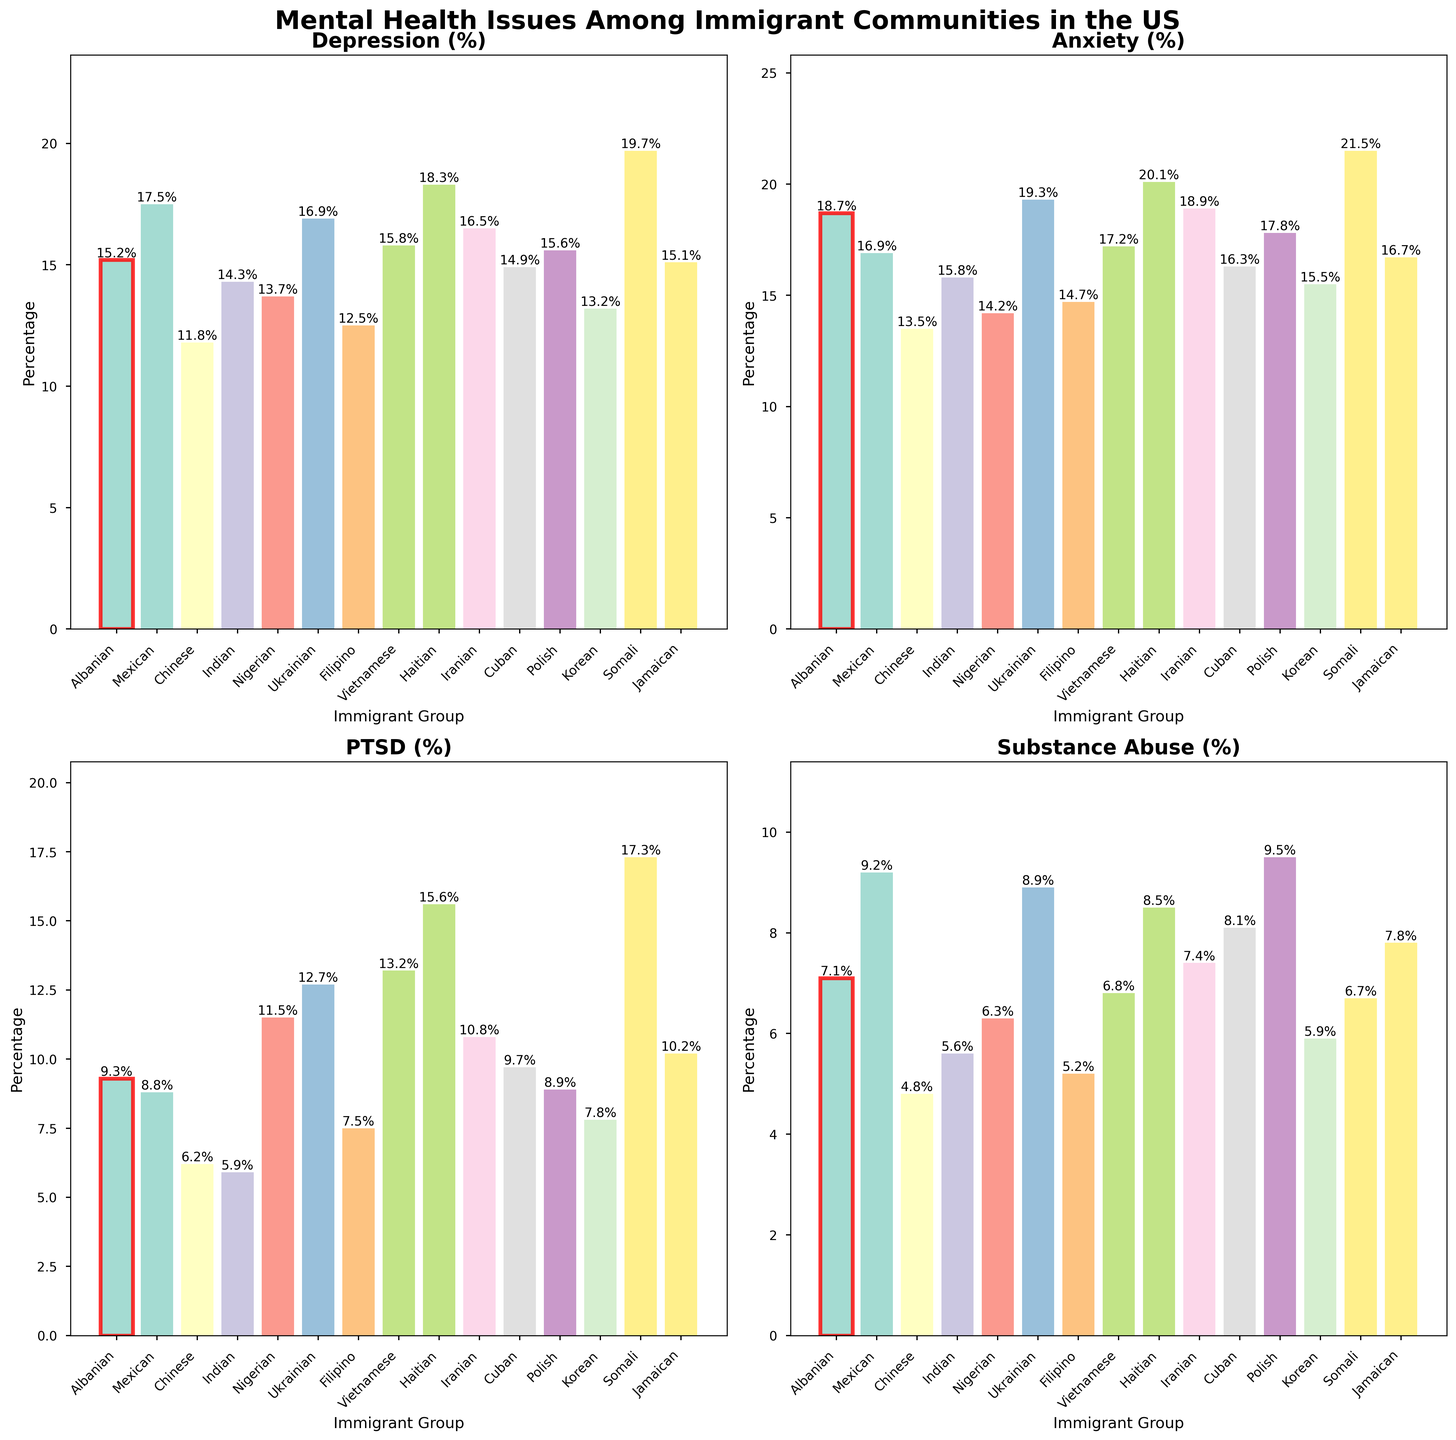Which group has the highest percentage of substance abuse? Look at the "Substance Abuse (%)" subplot and find the tallest bar. The Nigerian group has the highest percentage of substance abuse at 9.5%.
Answer: Nigerian Which immigrant group has the lowest percentage of PTSD? Refer to the "PTSD (%)" subplot and identify the shortest bar. The Indian group has the lowest percentage of PTSD at 5.9%.
Answer: Indian What's the average percentage of depression across all immigrant groups? Add the percentages of depression for all immigrant groups and divide by the number of groups. Calculation: (15.2 + 17.5 + 11.8 + 14.3 + 13.7 + 16.9 + 12.5 + 15.8 + 18.3 + 16.5 + 14.9 + 15.6 + 13.2 + 19.7 + 15.1) / 15 ≈ 15.3%
Answer: 15.3% How do the anxiety percentages of the Haitian and Somali groups compare visually? Both groups have their bars highlighted in the "Anxiety (%)" subplot. The Somali bar is slightly taller than the Haitian bar. The Somali group's anxiety percentage is 21.5%, and the Haitian group's anxiety percentage is 20.1%.
Answer: Somali > Haitian Which group has a higher percentage of PTSD, the Vietnamese or the Ukrainian? Look at the heights of the bars in the "PTSD (%)" subplot for the Vietnamese and Ukrainian groups. The Vietnamese group has a higher PTSD percentage (13.2%) compared to the Ukrainian group (12.7%).
Answer: Vietnamese Identify the immigrant group with a red-bordered bar in the subplots. The Albanian group's bars are highlighted with a red border in all subplots, making them easy to spot. The percentages for depression, anxiety, PTSD, and substance abuse are 15.2%, 18.7%, 9.3%, and 7.1%, respectively.
Answer: Albanian What's the total percentage of depression and anxiety in the Cuban group? Add the percentages of depression and anxiety for the Cuban group. The depression percentage is 14.9%, and the anxiety percentage is 16.3%, so the total is 14.9 + 16.3 = 31.2%.
Answer: 31.2% Which immigrant group has the highest percentage of depression, and what is that percentage? Look for the highest bar in the "Depression (%)" subplot. The Somali group has the highest depression percentage at 19.7%.
Answer: Somali, 19.7% Compare the substance abuse percentages of the Mexican and Iranian groups. In the "Substance Abuse (%)" subplot, the Mexican group has a slightly higher bar than the Iranian group. The Mexican group's substance abuse percentage is 9.2%, and the Iranian group's is 7.4%.
Answer: Mexican > Iranian 